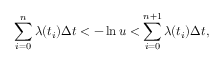<formula> <loc_0><loc_0><loc_500><loc_500>\sum _ { i = 0 } ^ { n } \lambda ( t _ { i } ) \Delta t < - \ln u < \sum _ { i = 0 } ^ { n + 1 } \lambda ( t _ { i } ) \Delta t ,</formula> 